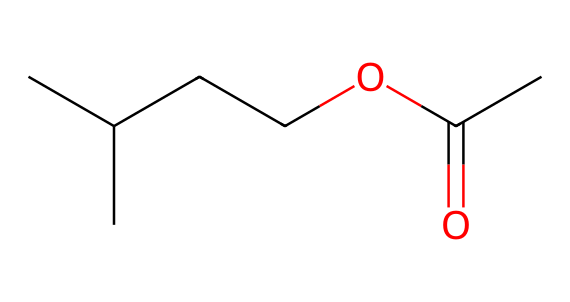What is the total number of carbon atoms in the molecule? By examining the SMILES representation, we can count the 'C' characters, which represent carbon atoms. There are a total of 5 'C's in the string, indicating five carbon atoms in the molecular structure.
Answer: five How many oxygen atoms are present in the molecule? The SMILES notation includes 'O' characters, which denote oxygen atoms. In this case, there are two 'O's in the representation, which means there are two oxygen atoms in the structure.
Answer: two What type of functional group is identified in this chemical? This molecule contains a carbonyl group (C=O), as indicated by the "=O" in the notation. This indicates that it falls under the category of esters.
Answer: ester Does this chemical contain any nitrogen atoms? By reviewing the SMILES string, we can confirm the absence of the letter 'N.' Therefore, we deduce that there are no nitrogen atoms present in this molecule.
Answer: no Can you identify the molecular weight of this compound? To find the molecular weight, we need to account for the number of each type of atom: 5 carbons (5x12), 10 hydrogens (10x1), and 2 oxygens (2x16). Adding these weights together gives us a total of 86 g/mol.
Answer: 86 g/mol Is this chemical classified as a nitrile? Nitriles typically contain a carbon atom triple-bonded to a nitrogen atom (C≡N). Upon evaluating the structure in the SMILES notation, we notice that there is no such functional group present.
Answer: no What implication does the presence of alkyl chains have on the stability of this chemical? The structure includes branched alkyl groups, which generally enhance stability due to steric hindrance, reducing reactivity against nucleophiles. This indicates a more stable compound.
Answer: stable 